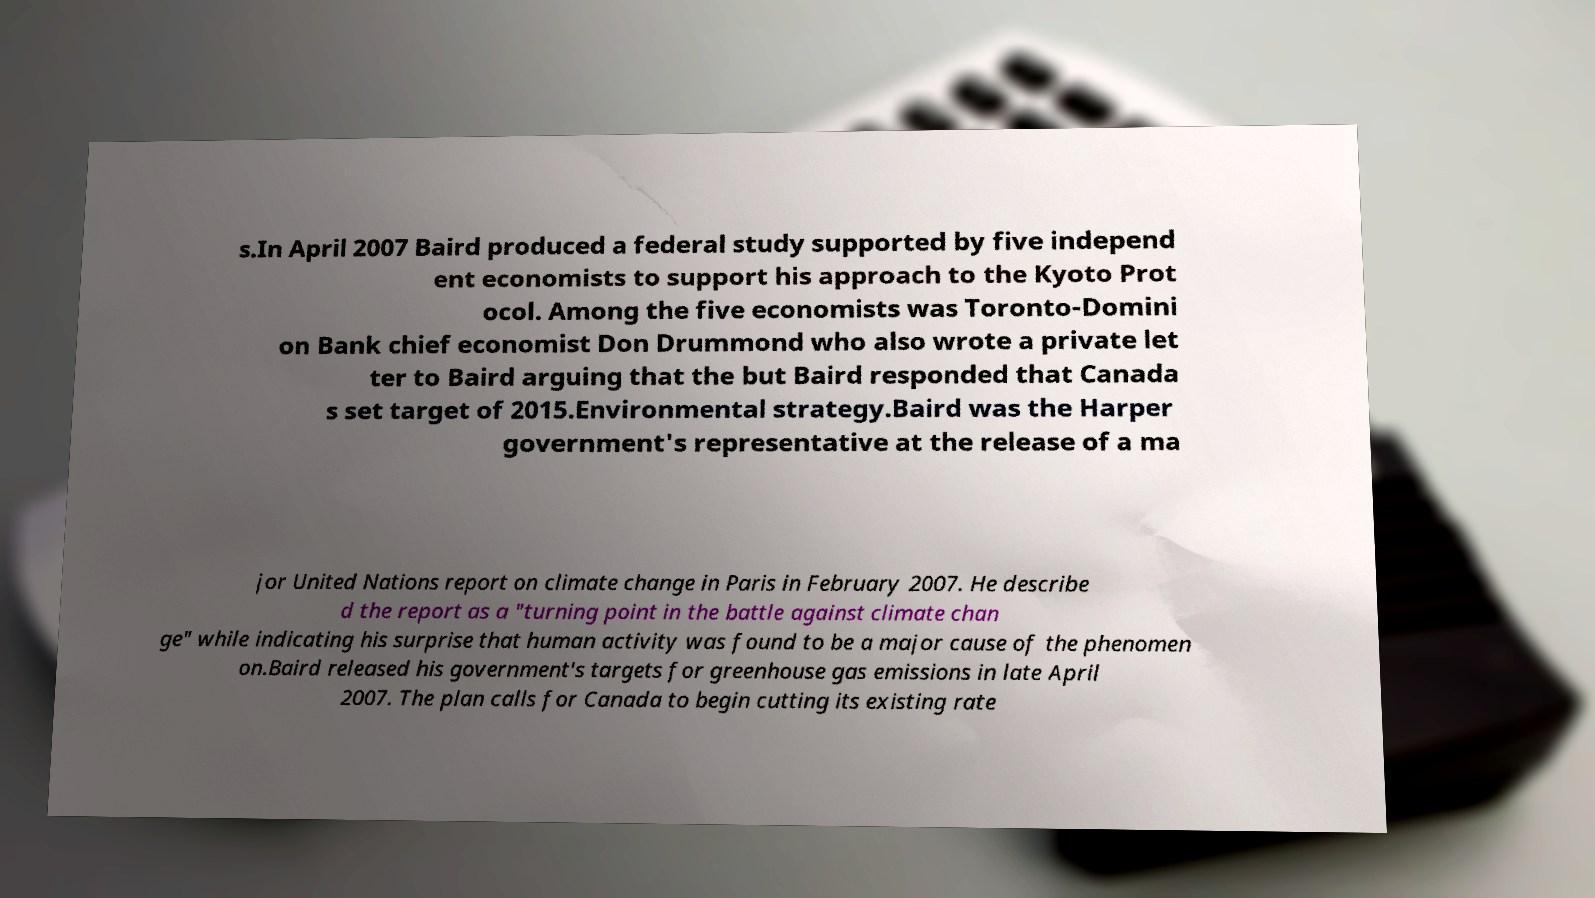Please read and relay the text visible in this image. What does it say? s.In April 2007 Baird produced a federal study supported by five independ ent economists to support his approach to the Kyoto Prot ocol. Among the five economists was Toronto-Domini on Bank chief economist Don Drummond who also wrote a private let ter to Baird arguing that the but Baird responded that Canada s set target of 2015.Environmental strategy.Baird was the Harper government's representative at the release of a ma jor United Nations report on climate change in Paris in February 2007. He describe d the report as a "turning point in the battle against climate chan ge" while indicating his surprise that human activity was found to be a major cause of the phenomen on.Baird released his government's targets for greenhouse gas emissions in late April 2007. The plan calls for Canada to begin cutting its existing rate 